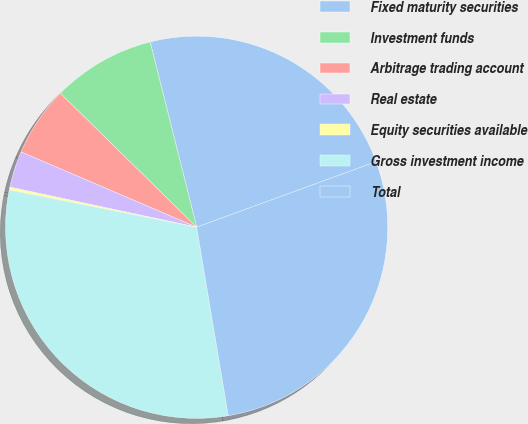Convert chart to OTSL. <chart><loc_0><loc_0><loc_500><loc_500><pie_chart><fcel>Fixed maturity securities<fcel>Investment funds<fcel>Arbitrage trading account<fcel>Real estate<fcel>Equity securities available<fcel>Gross investment income<fcel>Total<nl><fcel>23.34%<fcel>8.73%<fcel>5.91%<fcel>3.08%<fcel>0.25%<fcel>30.76%<fcel>27.93%<nl></chart> 